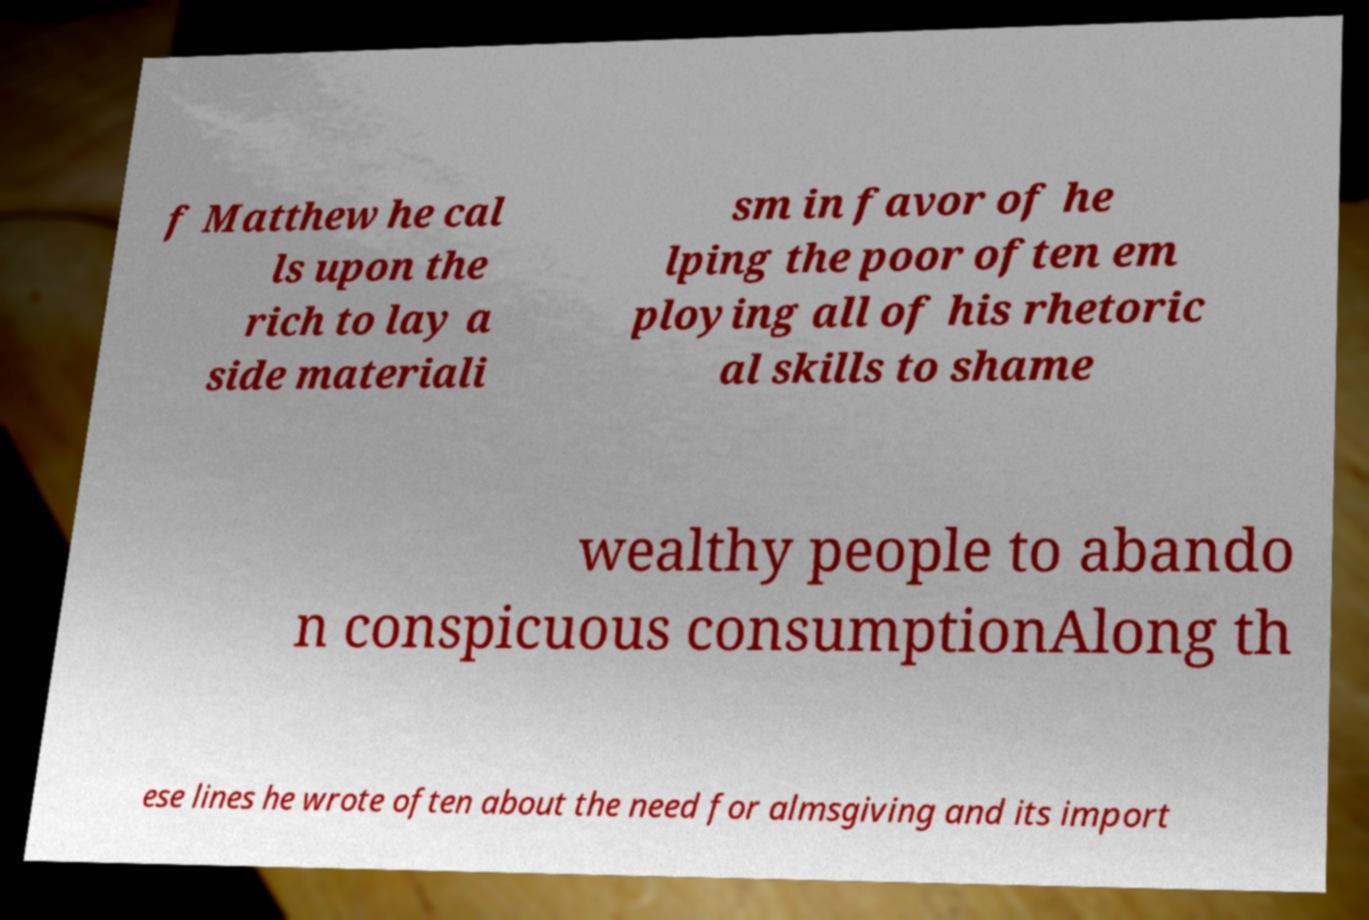Can you read and provide the text displayed in the image?This photo seems to have some interesting text. Can you extract and type it out for me? f Matthew he cal ls upon the rich to lay a side materiali sm in favor of he lping the poor often em ploying all of his rhetoric al skills to shame wealthy people to abando n conspicuous consumptionAlong th ese lines he wrote often about the need for almsgiving and its import 